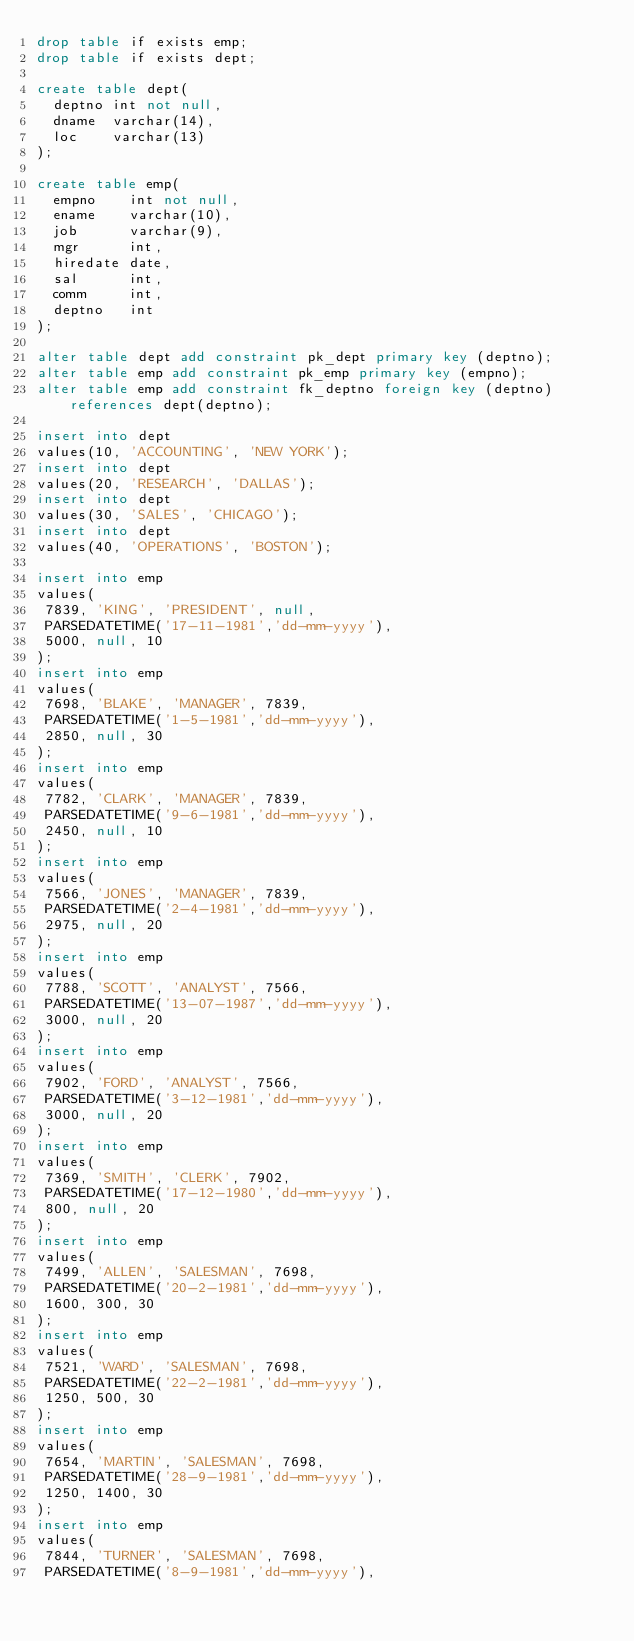Convert code to text. <code><loc_0><loc_0><loc_500><loc_500><_SQL_>drop table if exists emp;
drop table if exists dept;

create table dept(
  deptno int not null,
  dname  varchar(14),
  loc    varchar(13)
);
 
create table emp(
  empno    int not null,
  ename    varchar(10),
  job      varchar(9),
  mgr      int,
  hiredate date,
  sal      int,
  comm     int,
  deptno   int
);

alter table dept add constraint pk_dept primary key (deptno);
alter table emp add constraint pk_emp primary key (empno);
alter table emp add constraint fk_deptno foreign key (deptno) references dept(deptno);

insert into dept
values(10, 'ACCOUNTING', 'NEW YORK');
insert into dept
values(20, 'RESEARCH', 'DALLAS');
insert into dept
values(30, 'SALES', 'CHICAGO');
insert into dept
values(40, 'OPERATIONS', 'BOSTON');
 
insert into emp
values(
 7839, 'KING', 'PRESIDENT', null,
 PARSEDATETIME('17-11-1981','dd-mm-yyyy'),
 5000, null, 10
);
insert into emp
values(
 7698, 'BLAKE', 'MANAGER', 7839,
 PARSEDATETIME('1-5-1981','dd-mm-yyyy'),
 2850, null, 30
);
insert into emp
values(
 7782, 'CLARK', 'MANAGER', 7839,
 PARSEDATETIME('9-6-1981','dd-mm-yyyy'),
 2450, null, 10
);
insert into emp
values(
 7566, 'JONES', 'MANAGER', 7839,
 PARSEDATETIME('2-4-1981','dd-mm-yyyy'),
 2975, null, 20
);
insert into emp
values(
 7788, 'SCOTT', 'ANALYST', 7566,
 PARSEDATETIME('13-07-1987','dd-mm-yyyy'),
 3000, null, 20
);
insert into emp
values(
 7902, 'FORD', 'ANALYST', 7566,
 PARSEDATETIME('3-12-1981','dd-mm-yyyy'),
 3000, null, 20
);
insert into emp
values(
 7369, 'SMITH', 'CLERK', 7902,
 PARSEDATETIME('17-12-1980','dd-mm-yyyy'),
 800, null, 20
);
insert into emp
values(
 7499, 'ALLEN', 'SALESMAN', 7698,
 PARSEDATETIME('20-2-1981','dd-mm-yyyy'),
 1600, 300, 30
);
insert into emp
values(
 7521, 'WARD', 'SALESMAN', 7698,
 PARSEDATETIME('22-2-1981','dd-mm-yyyy'),
 1250, 500, 30
);
insert into emp
values(
 7654, 'MARTIN', 'SALESMAN', 7698,
 PARSEDATETIME('28-9-1981','dd-mm-yyyy'),
 1250, 1400, 30
);
insert into emp
values(
 7844, 'TURNER', 'SALESMAN', 7698,
 PARSEDATETIME('8-9-1981','dd-mm-yyyy'),</code> 